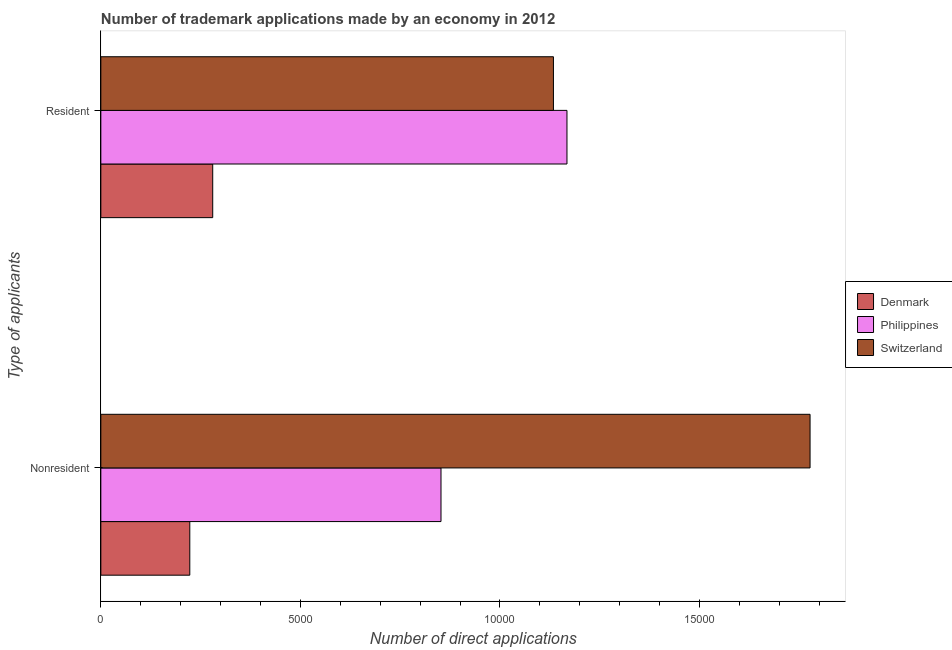How many different coloured bars are there?
Your answer should be very brief. 3. Are the number of bars on each tick of the Y-axis equal?
Offer a very short reply. Yes. How many bars are there on the 1st tick from the bottom?
Your answer should be very brief. 3. What is the label of the 2nd group of bars from the top?
Ensure brevity in your answer.  Nonresident. What is the number of trademark applications made by non residents in Switzerland?
Your response must be concise. 1.78e+04. Across all countries, what is the maximum number of trademark applications made by residents?
Your response must be concise. 1.17e+04. Across all countries, what is the minimum number of trademark applications made by residents?
Your answer should be very brief. 2803. In which country was the number of trademark applications made by non residents maximum?
Offer a very short reply. Switzerland. What is the total number of trademark applications made by non residents in the graph?
Your answer should be compact. 2.85e+04. What is the difference between the number of trademark applications made by non residents in Denmark and that in Switzerland?
Offer a very short reply. -1.55e+04. What is the difference between the number of trademark applications made by non residents in Philippines and the number of trademark applications made by residents in Switzerland?
Make the answer very short. -2817. What is the average number of trademark applications made by residents per country?
Make the answer very short. 8607.33. What is the difference between the number of trademark applications made by non residents and number of trademark applications made by residents in Denmark?
Your answer should be compact. -574. What is the ratio of the number of trademark applications made by non residents in Philippines to that in Denmark?
Give a very brief answer. 3.82. Is the number of trademark applications made by non residents in Denmark less than that in Philippines?
Your answer should be very brief. Yes. In how many countries, is the number of trademark applications made by residents greater than the average number of trademark applications made by residents taken over all countries?
Your answer should be compact. 2. What does the 1st bar from the top in Resident represents?
Offer a very short reply. Switzerland. What does the 3rd bar from the bottom in Resident represents?
Offer a very short reply. Switzerland. What is the difference between two consecutive major ticks on the X-axis?
Offer a terse response. 5000. What is the title of the graph?
Make the answer very short. Number of trademark applications made by an economy in 2012. What is the label or title of the X-axis?
Ensure brevity in your answer.  Number of direct applications. What is the label or title of the Y-axis?
Your answer should be very brief. Type of applicants. What is the Number of direct applications of Denmark in Nonresident?
Offer a very short reply. 2229. What is the Number of direct applications in Philippines in Nonresident?
Make the answer very short. 8523. What is the Number of direct applications in Switzerland in Nonresident?
Give a very brief answer. 1.78e+04. What is the Number of direct applications in Denmark in Resident?
Your answer should be very brief. 2803. What is the Number of direct applications of Philippines in Resident?
Ensure brevity in your answer.  1.17e+04. What is the Number of direct applications in Switzerland in Resident?
Your answer should be compact. 1.13e+04. Across all Type of applicants, what is the maximum Number of direct applications in Denmark?
Your response must be concise. 2803. Across all Type of applicants, what is the maximum Number of direct applications of Philippines?
Your answer should be very brief. 1.17e+04. Across all Type of applicants, what is the maximum Number of direct applications in Switzerland?
Provide a succinct answer. 1.78e+04. Across all Type of applicants, what is the minimum Number of direct applications of Denmark?
Provide a succinct answer. 2229. Across all Type of applicants, what is the minimum Number of direct applications in Philippines?
Offer a very short reply. 8523. Across all Type of applicants, what is the minimum Number of direct applications in Switzerland?
Ensure brevity in your answer.  1.13e+04. What is the total Number of direct applications of Denmark in the graph?
Your response must be concise. 5032. What is the total Number of direct applications of Philippines in the graph?
Your answer should be very brief. 2.02e+04. What is the total Number of direct applications of Switzerland in the graph?
Your response must be concise. 2.91e+04. What is the difference between the Number of direct applications in Denmark in Nonresident and that in Resident?
Offer a very short reply. -574. What is the difference between the Number of direct applications in Philippines in Nonresident and that in Resident?
Ensure brevity in your answer.  -3156. What is the difference between the Number of direct applications in Switzerland in Nonresident and that in Resident?
Offer a terse response. 6430. What is the difference between the Number of direct applications in Denmark in Nonresident and the Number of direct applications in Philippines in Resident?
Ensure brevity in your answer.  -9450. What is the difference between the Number of direct applications of Denmark in Nonresident and the Number of direct applications of Switzerland in Resident?
Offer a terse response. -9111. What is the difference between the Number of direct applications in Philippines in Nonresident and the Number of direct applications in Switzerland in Resident?
Offer a very short reply. -2817. What is the average Number of direct applications in Denmark per Type of applicants?
Provide a short and direct response. 2516. What is the average Number of direct applications of Philippines per Type of applicants?
Your answer should be compact. 1.01e+04. What is the average Number of direct applications in Switzerland per Type of applicants?
Ensure brevity in your answer.  1.46e+04. What is the difference between the Number of direct applications of Denmark and Number of direct applications of Philippines in Nonresident?
Ensure brevity in your answer.  -6294. What is the difference between the Number of direct applications of Denmark and Number of direct applications of Switzerland in Nonresident?
Your answer should be compact. -1.55e+04. What is the difference between the Number of direct applications of Philippines and Number of direct applications of Switzerland in Nonresident?
Offer a very short reply. -9247. What is the difference between the Number of direct applications in Denmark and Number of direct applications in Philippines in Resident?
Offer a terse response. -8876. What is the difference between the Number of direct applications of Denmark and Number of direct applications of Switzerland in Resident?
Offer a very short reply. -8537. What is the difference between the Number of direct applications in Philippines and Number of direct applications in Switzerland in Resident?
Your response must be concise. 339. What is the ratio of the Number of direct applications in Denmark in Nonresident to that in Resident?
Offer a very short reply. 0.8. What is the ratio of the Number of direct applications of Philippines in Nonresident to that in Resident?
Keep it short and to the point. 0.73. What is the ratio of the Number of direct applications in Switzerland in Nonresident to that in Resident?
Your answer should be very brief. 1.57. What is the difference between the highest and the second highest Number of direct applications in Denmark?
Offer a terse response. 574. What is the difference between the highest and the second highest Number of direct applications of Philippines?
Your response must be concise. 3156. What is the difference between the highest and the second highest Number of direct applications of Switzerland?
Keep it short and to the point. 6430. What is the difference between the highest and the lowest Number of direct applications in Denmark?
Keep it short and to the point. 574. What is the difference between the highest and the lowest Number of direct applications of Philippines?
Ensure brevity in your answer.  3156. What is the difference between the highest and the lowest Number of direct applications in Switzerland?
Ensure brevity in your answer.  6430. 